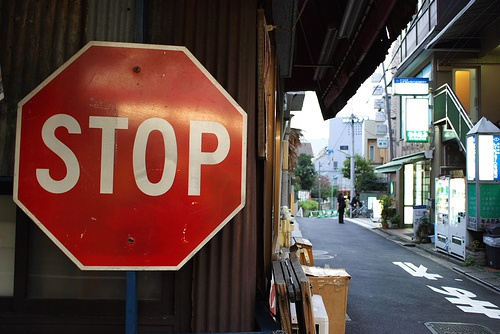Describe the objects in this image and their specific colors. I can see stop sign in black, maroon, darkgray, and brown tones, people in black, gray, and blue tones, and people in black, gray, and darkgray tones in this image. 